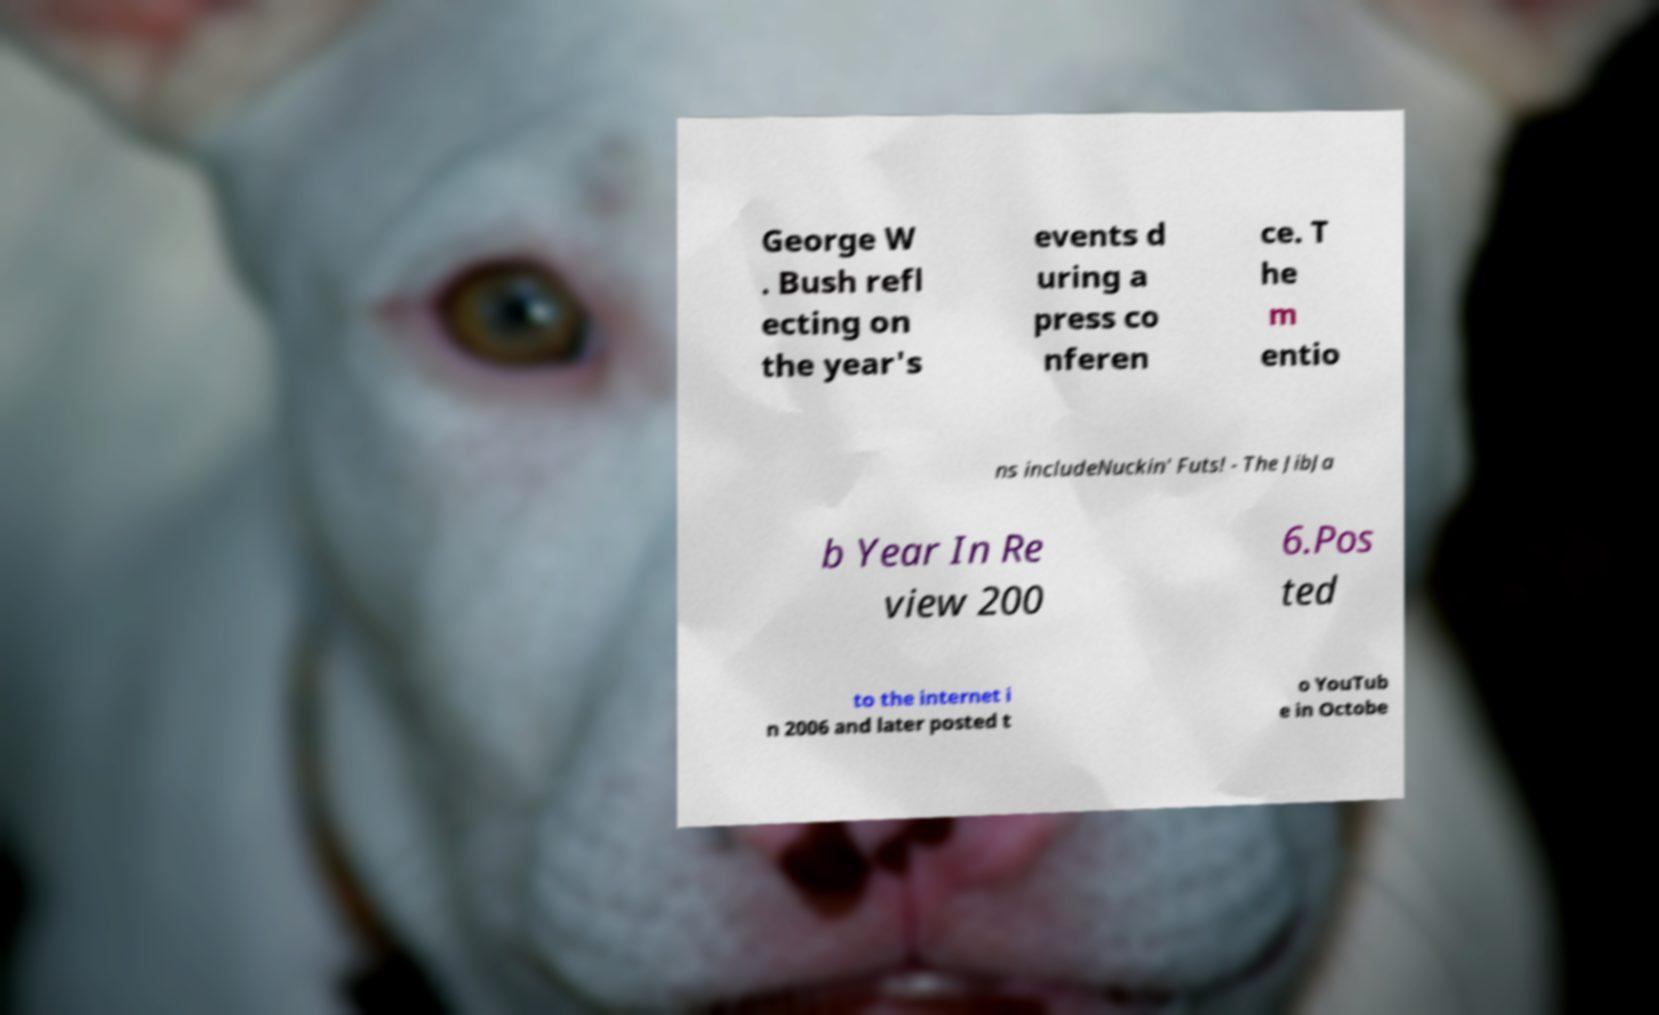There's text embedded in this image that I need extracted. Can you transcribe it verbatim? George W . Bush refl ecting on the year's events d uring a press co nferen ce. T he m entio ns includeNuckin' Futs! - The JibJa b Year In Re view 200 6.Pos ted to the internet i n 2006 and later posted t o YouTub e in Octobe 